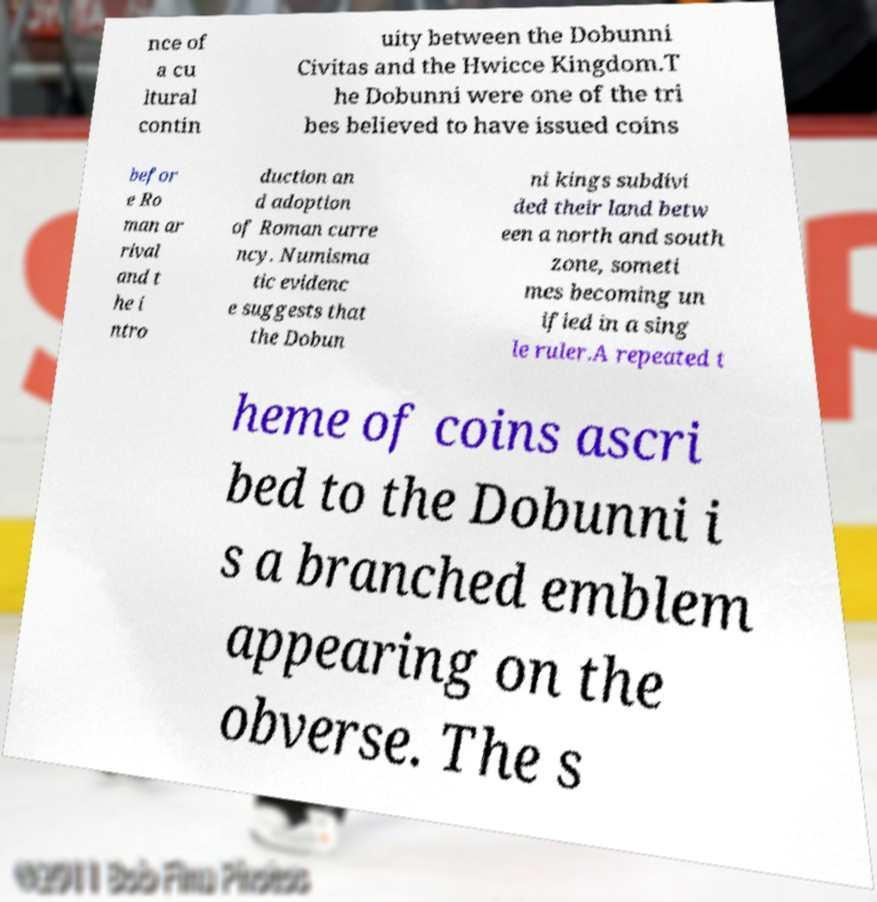For documentation purposes, I need the text within this image transcribed. Could you provide that? nce of a cu ltural contin uity between the Dobunni Civitas and the Hwicce Kingdom.T he Dobunni were one of the tri bes believed to have issued coins befor e Ro man ar rival and t he i ntro duction an d adoption of Roman curre ncy. Numisma tic evidenc e suggests that the Dobun ni kings subdivi ded their land betw een a north and south zone, someti mes becoming un ified in a sing le ruler.A repeated t heme of coins ascri bed to the Dobunni i s a branched emblem appearing on the obverse. The s 